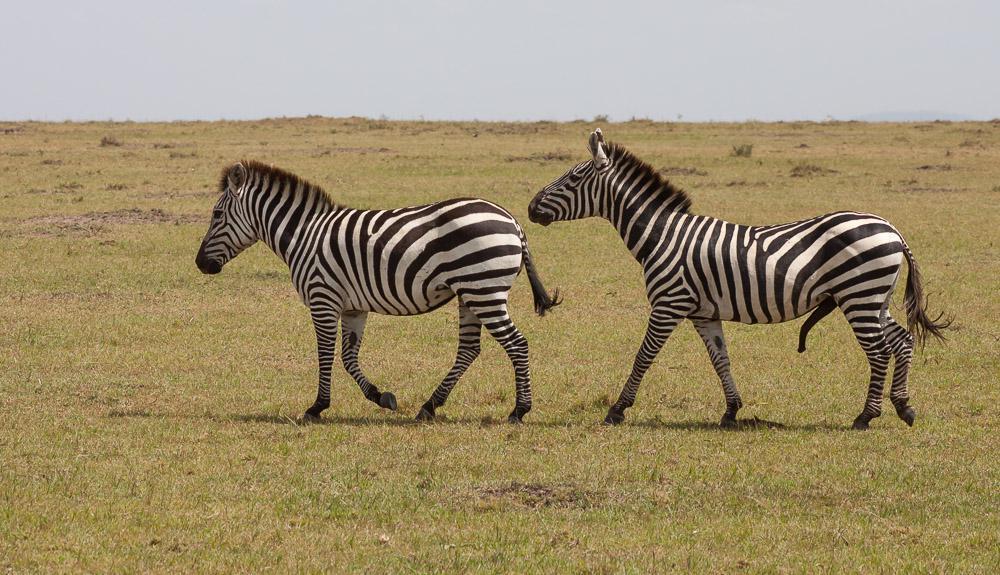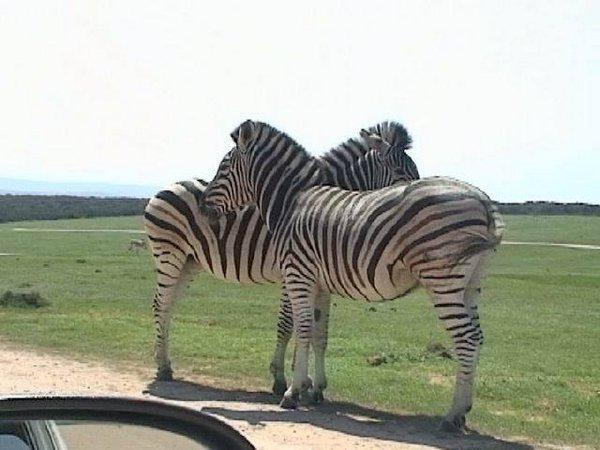The first image is the image on the left, the second image is the image on the right. Given the left and right images, does the statement "In one image there are two zebras walking in the same direction." hold true? Answer yes or no. Yes. The first image is the image on the left, the second image is the image on the right. Assess this claim about the two images: "An image shows two zebras standing close together with their heads facing in opposite directions.". Correct or not? Answer yes or no. Yes. 